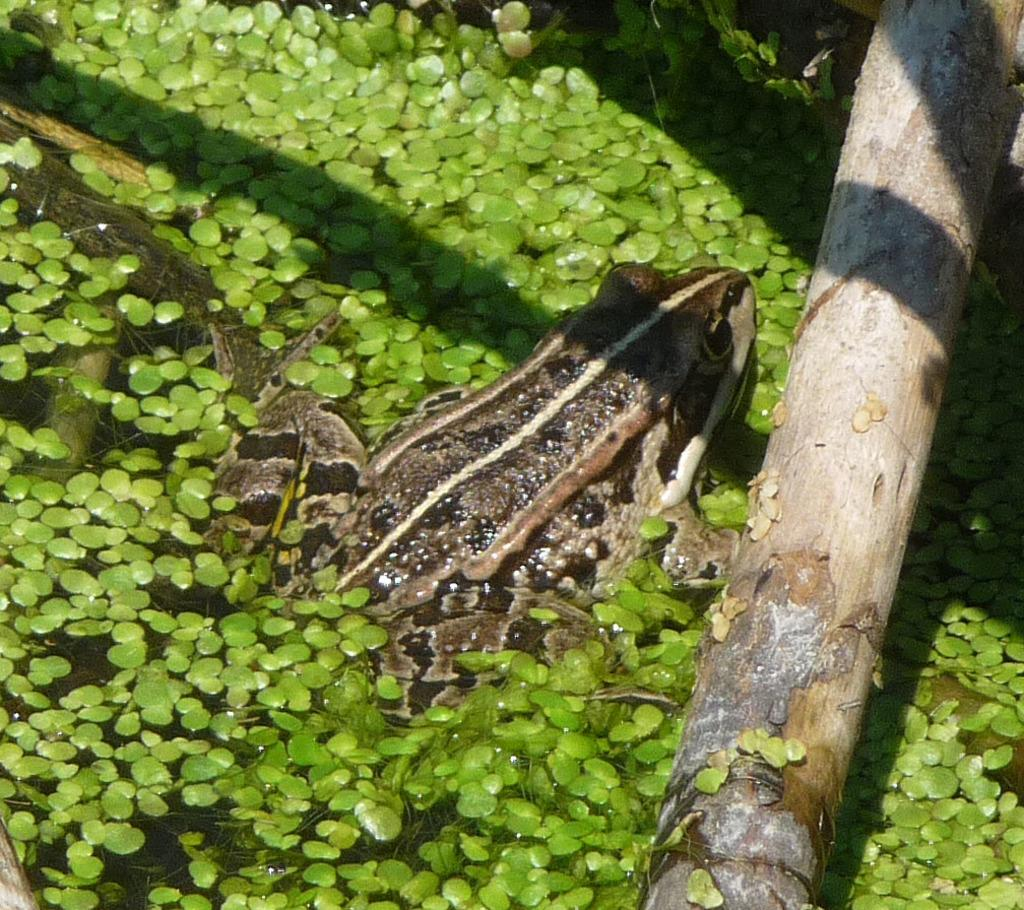What animal can be seen in the image? There is a frog in the image. Where is the frog located? The frog is in the water. What type of vegetation is present in the image? There are leaves in the image. What color are the leaves? The leaves are green in color. What else can be seen in the image besides the frog and leaves? There is a tree branch visible in the image. How many fangs does the frog have in the image? Frogs do not have fangs, so this detail cannot be observed in the image. 